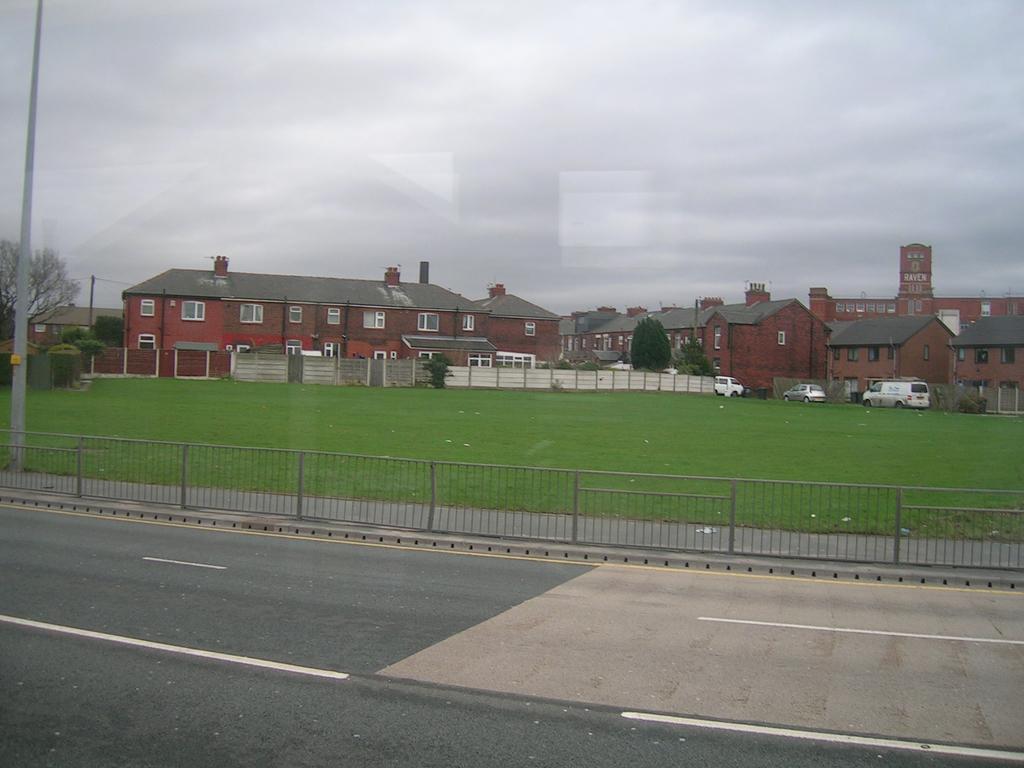Please provide a concise description of this image. In this image, we can see buildings, trees, vehicles and there are fences and poles. At the top, there is sky and at the bottom, there is ground and a road. 